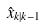Convert formula to latex. <formula><loc_0><loc_0><loc_500><loc_500>\hat { x } _ { k | k - 1 }</formula> 